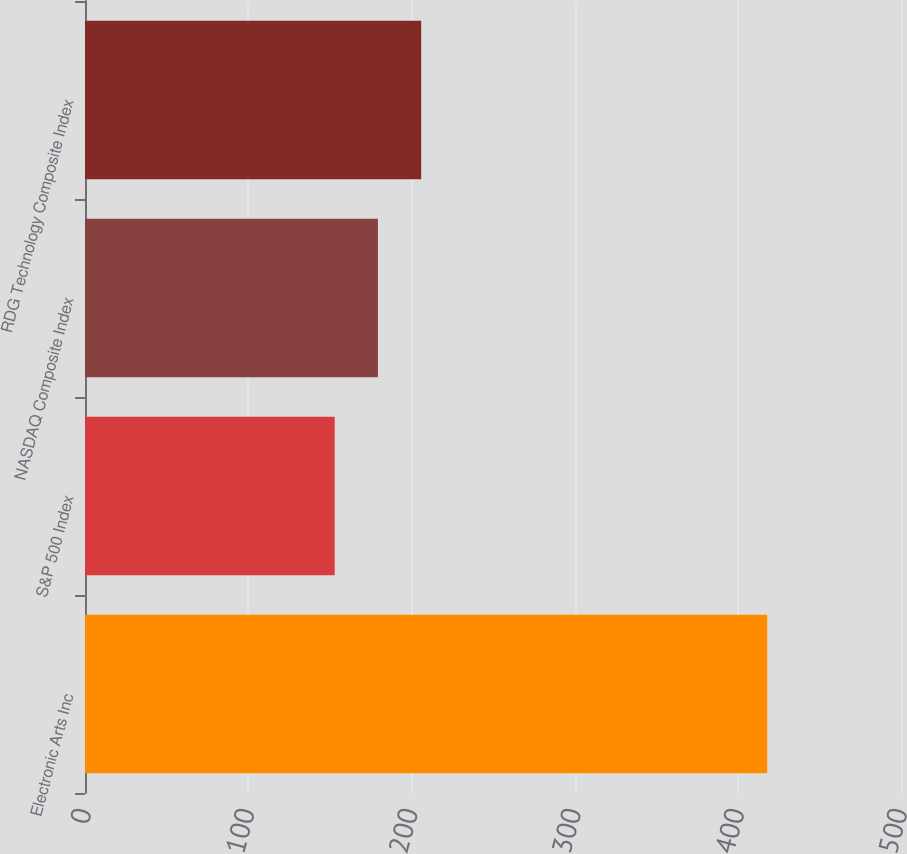Convert chart to OTSL. <chart><loc_0><loc_0><loc_500><loc_500><bar_chart><fcel>Electronic Arts Inc<fcel>S&P 500 Index<fcel>NASDAQ Composite Index<fcel>RDG Technology Composite Index<nl><fcel>418<fcel>153<fcel>179.5<fcel>206<nl></chart> 